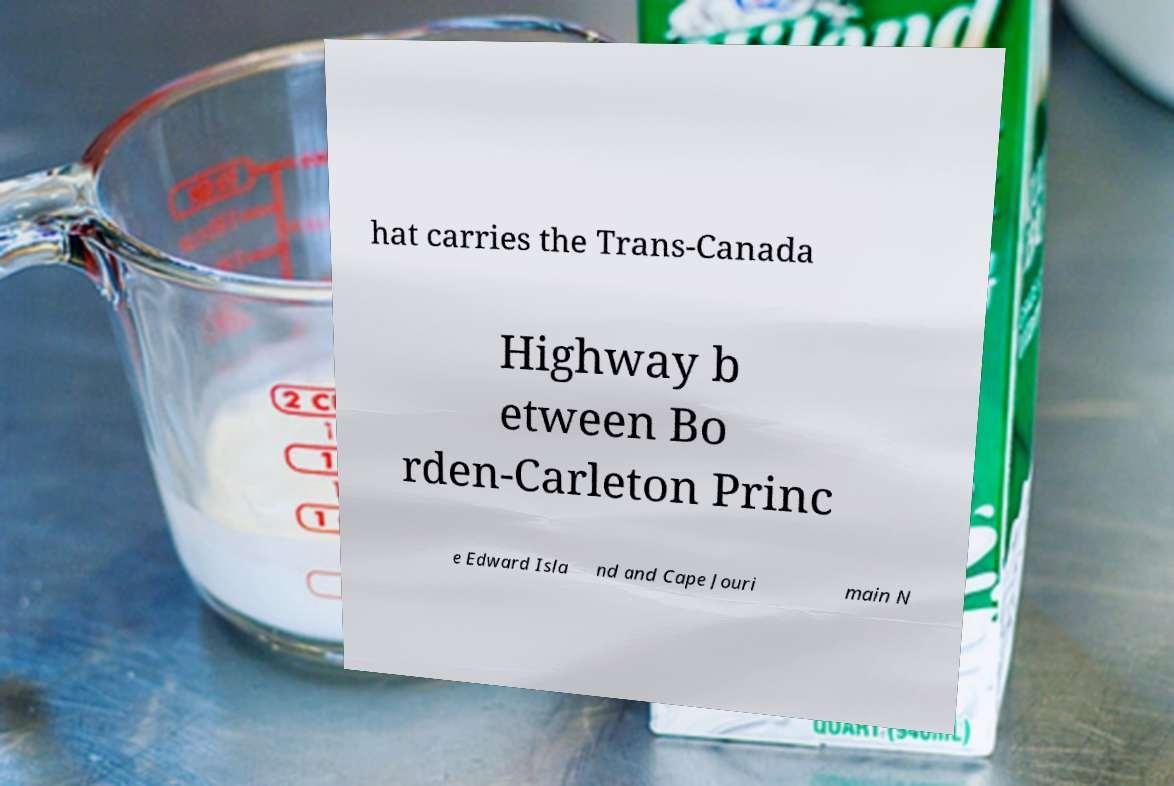What messages or text are displayed in this image? I need them in a readable, typed format. hat carries the Trans-Canada Highway b etween Bo rden-Carleton Princ e Edward Isla nd and Cape Jouri main N 